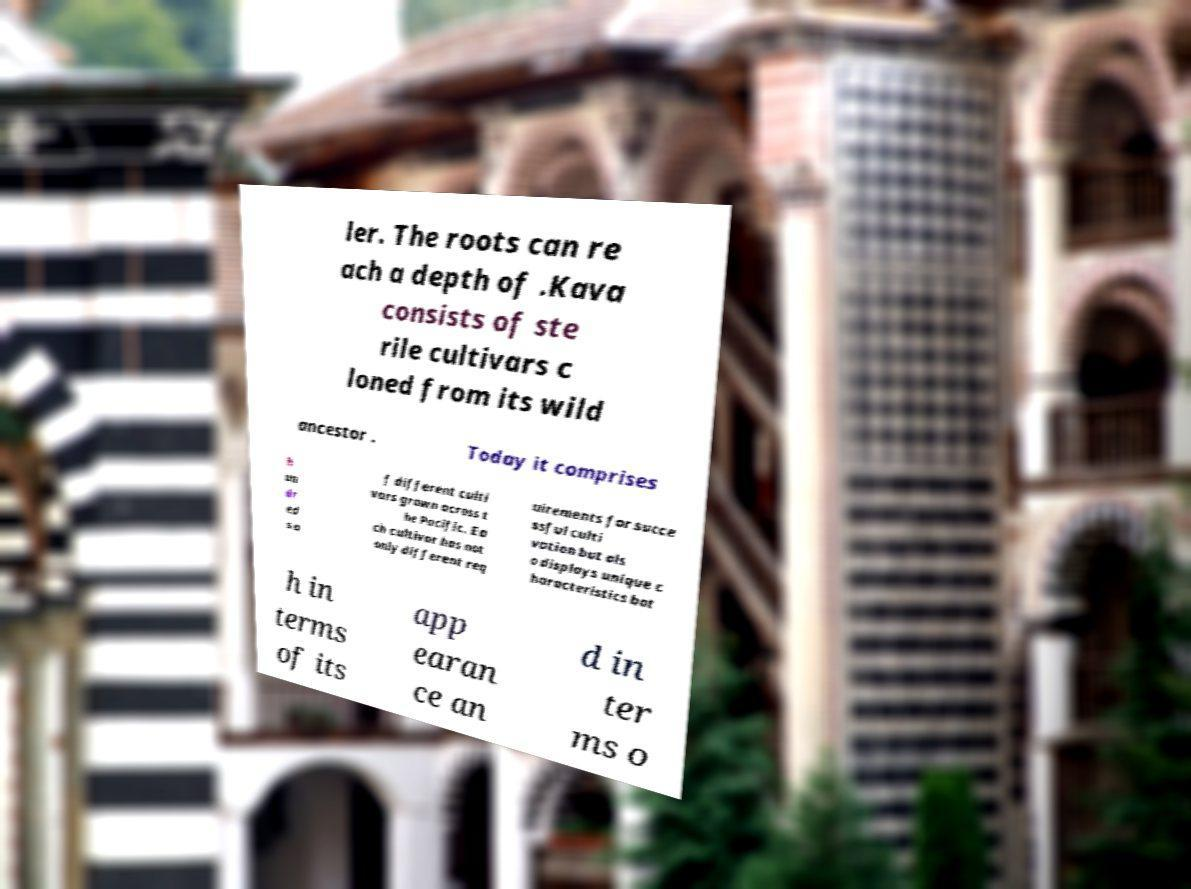Could you assist in decoding the text presented in this image and type it out clearly? ler. The roots can re ach a depth of .Kava consists of ste rile cultivars c loned from its wild ancestor . Today it comprises h un dr ed s o f different culti vars grown across t he Pacific. Ea ch cultivar has not only different req uirements for succe ssful culti vation but als o displays unique c haracteristics bot h in terms of its app earan ce an d in ter ms o 